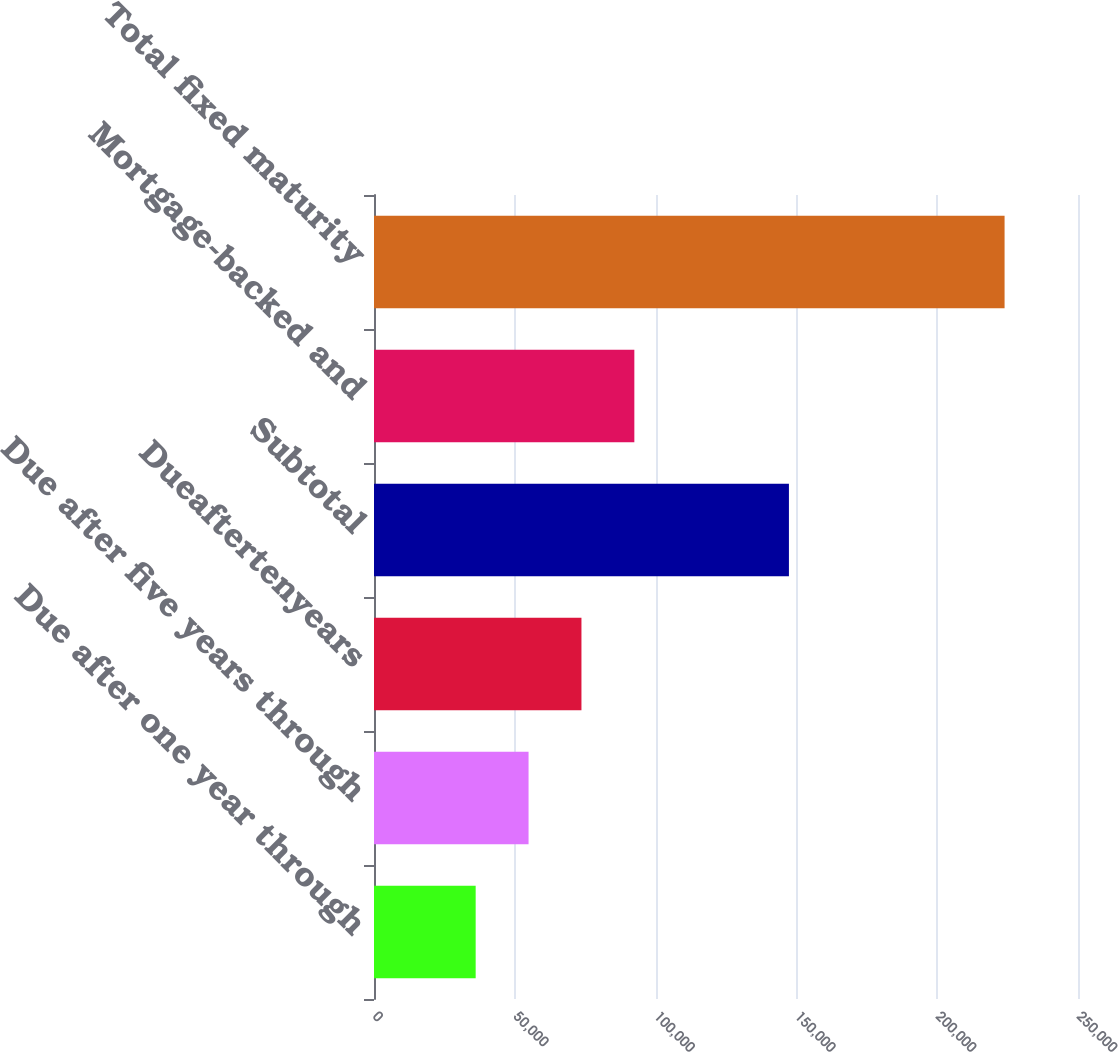<chart> <loc_0><loc_0><loc_500><loc_500><bar_chart><fcel>Due after one year through<fcel>Due after five years through<fcel>Dueaftertenyears<fcel>Subtotal<fcel>Mortgage-backed and<fcel>Total fixed maturity<nl><fcel>36105<fcel>54887.1<fcel>73669.2<fcel>147346<fcel>92451.3<fcel>223926<nl></chart> 